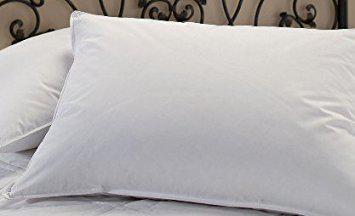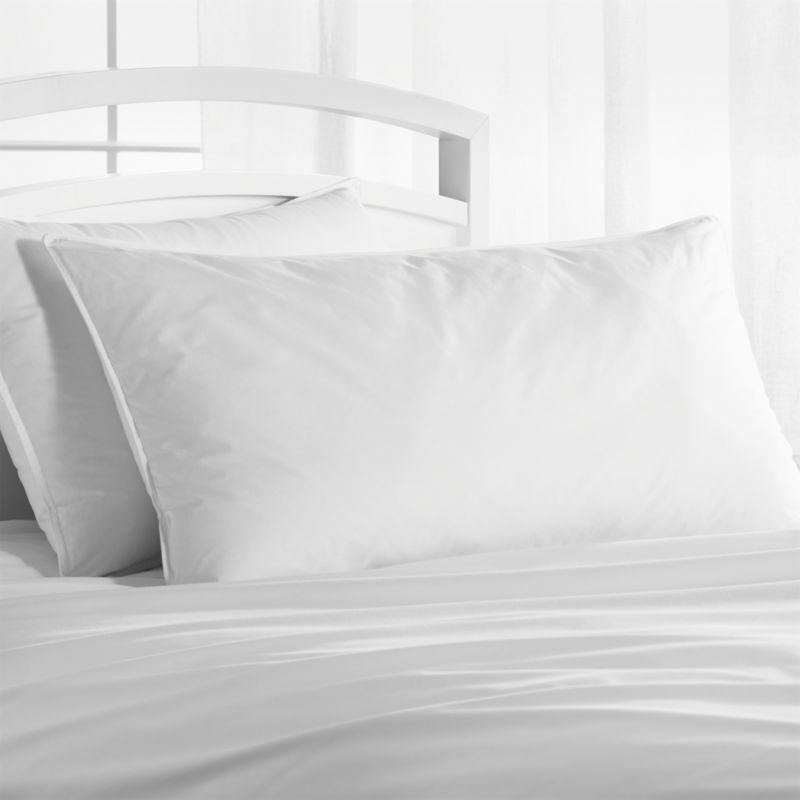The first image is the image on the left, the second image is the image on the right. Considering the images on both sides, is "An image shows a bed with tufted headboard and at least six pillows." valid? Answer yes or no. No. The first image is the image on the left, the second image is the image on the right. Examine the images to the left and right. Is the description "The pillows in the image on the left are propped against a padded headboard." accurate? Answer yes or no. No. 